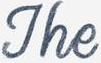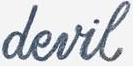Identify the words shown in these images in order, separated by a semicolon. The; devil 